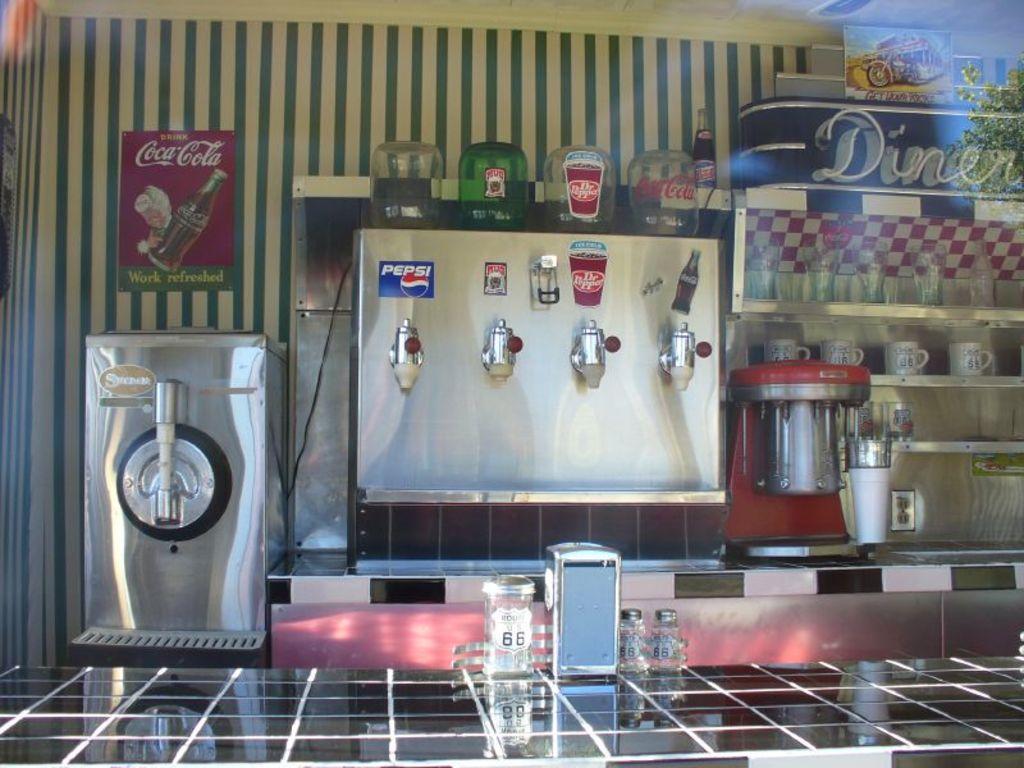What brand of soda is in blue?
Give a very brief answer. Pepsi. What brand of soda is on a sign on the wall?
Your answer should be very brief. Coca cola. 